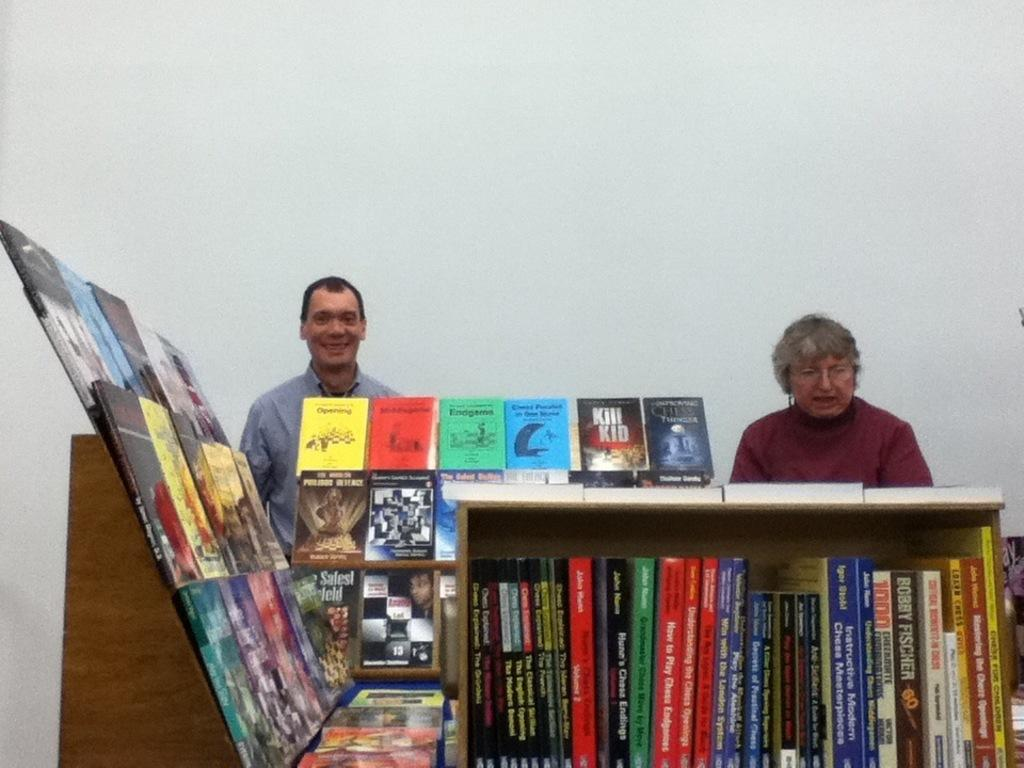<image>
Share a concise interpretation of the image provided. A large collection of books includes material on Bobby Fischer and titles such as How to Play Chess Explained. 